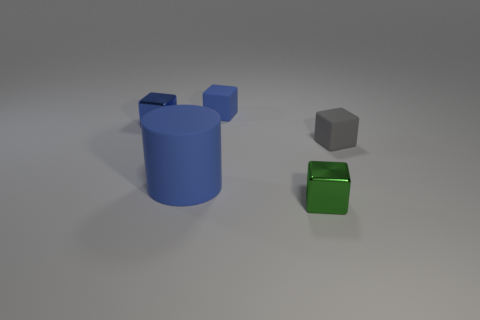Can you tell me what colors the objects in the image are? Certainly! In the image, there is a large blue cylinder, a smaller green cube, and an even smaller gray cube. 